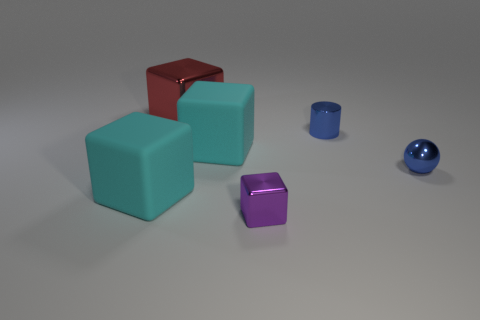Add 2 yellow things. How many objects exist? 8 Subtract all purple blocks. How many blocks are left? 3 Subtract all large red shiny cubes. How many cubes are left? 3 Subtract 0 purple cylinders. How many objects are left? 6 Subtract all spheres. How many objects are left? 5 Subtract 1 cylinders. How many cylinders are left? 0 Subtract all cyan cylinders. Subtract all purple spheres. How many cylinders are left? 1 Subtract all brown cylinders. How many yellow balls are left? 0 Subtract all cubes. Subtract all tiny blue metal cylinders. How many objects are left? 1 Add 4 tiny purple things. How many tiny purple things are left? 5 